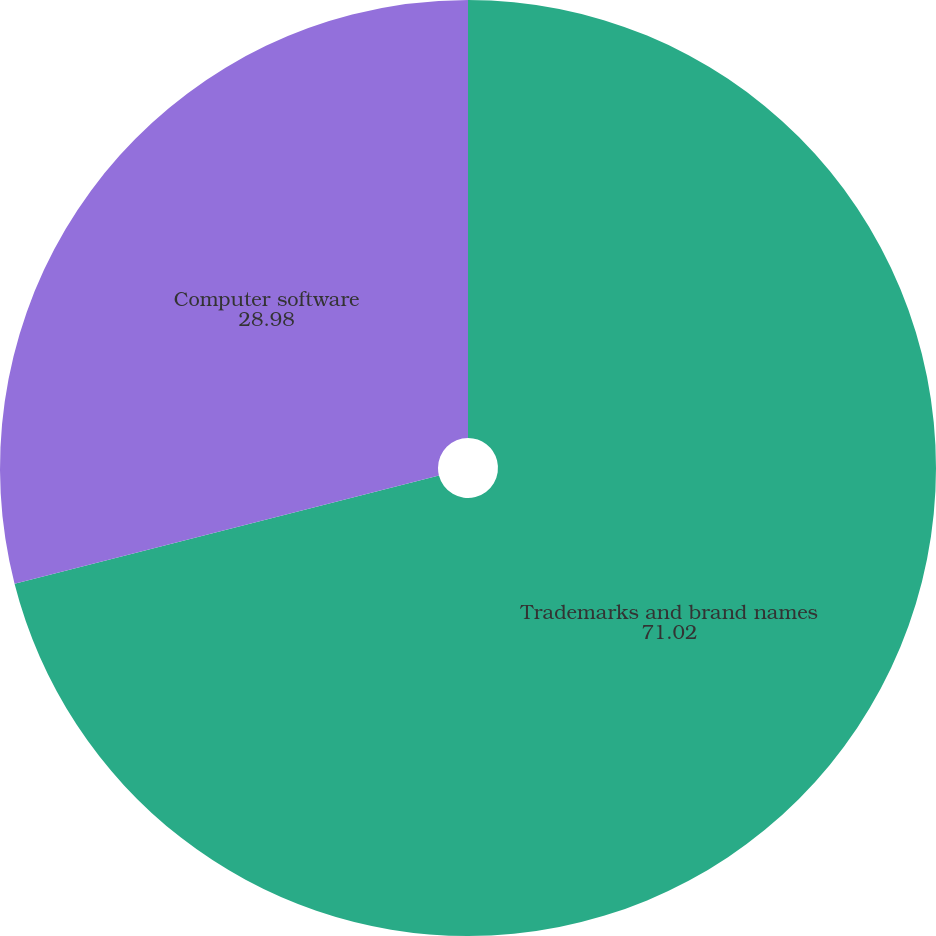Convert chart to OTSL. <chart><loc_0><loc_0><loc_500><loc_500><pie_chart><fcel>Trademarks and brand names<fcel>Computer software<nl><fcel>71.02%<fcel>28.98%<nl></chart> 